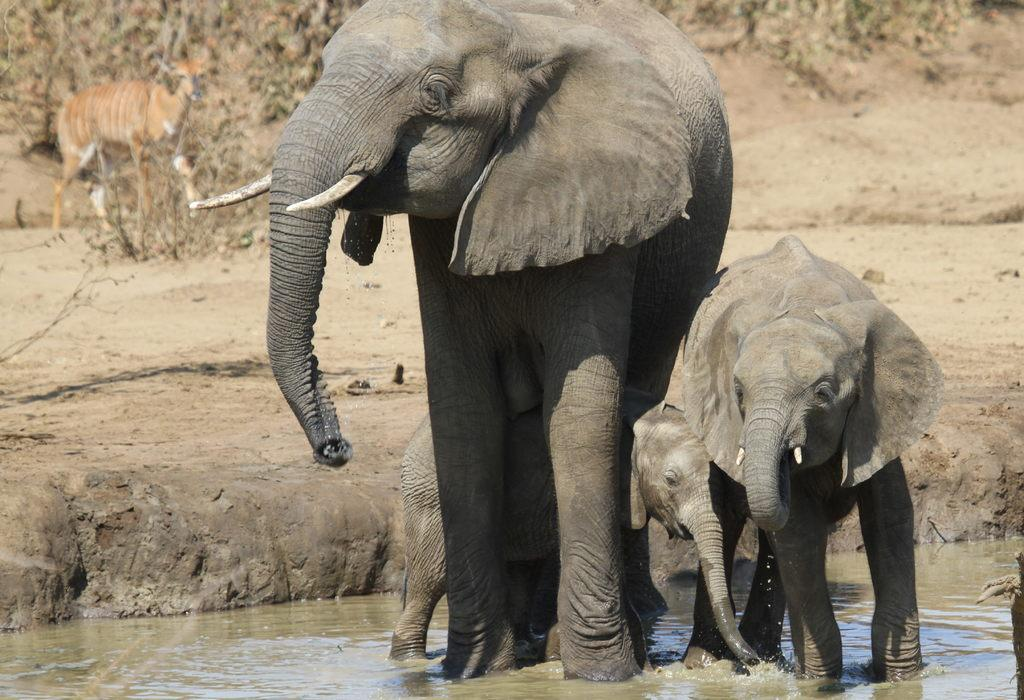What animals are present in the image? There are elephants in the image. Are there any young elephants in the image? Yes, there are calves in the image. Where are the elephants and calves located? The elephants and calves are in water. What can be seen in the background of the image? There is a deer and plants in the background of the image. What type of slip can be seen on the elephants' feet in the image? There is no slip present on the elephants' feet in the image; they are in water and do not have any footwear. 